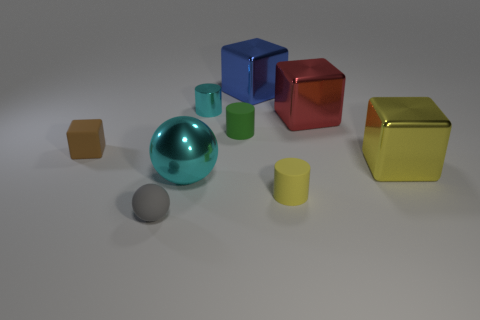Are the tiny yellow thing and the gray object made of the same material?
Provide a short and direct response. Yes. Are there more yellow things behind the big cyan metallic ball than gray objects?
Offer a very short reply. No. The sphere in front of the small rubber cylinder on the right side of the big blue shiny block right of the tiny green object is made of what material?
Your answer should be compact. Rubber. How many objects are either big green metal blocks or blue cubes that are to the right of the shiny cylinder?
Provide a succinct answer. 1. Is the color of the sphere that is to the right of the small gray object the same as the matte cube?
Make the answer very short. No. Are there more small things in front of the gray rubber ball than cyan metallic balls to the left of the big cyan object?
Ensure brevity in your answer.  No. Is there any other thing of the same color as the matte sphere?
Provide a short and direct response. No. What number of things are either large cyan metallic objects or green matte cylinders?
Offer a terse response. 2. Does the rubber thing that is left of the gray thing have the same size as the yellow cube?
Give a very brief answer. No. What number of other things are the same size as the cyan shiny ball?
Provide a succinct answer. 3. 